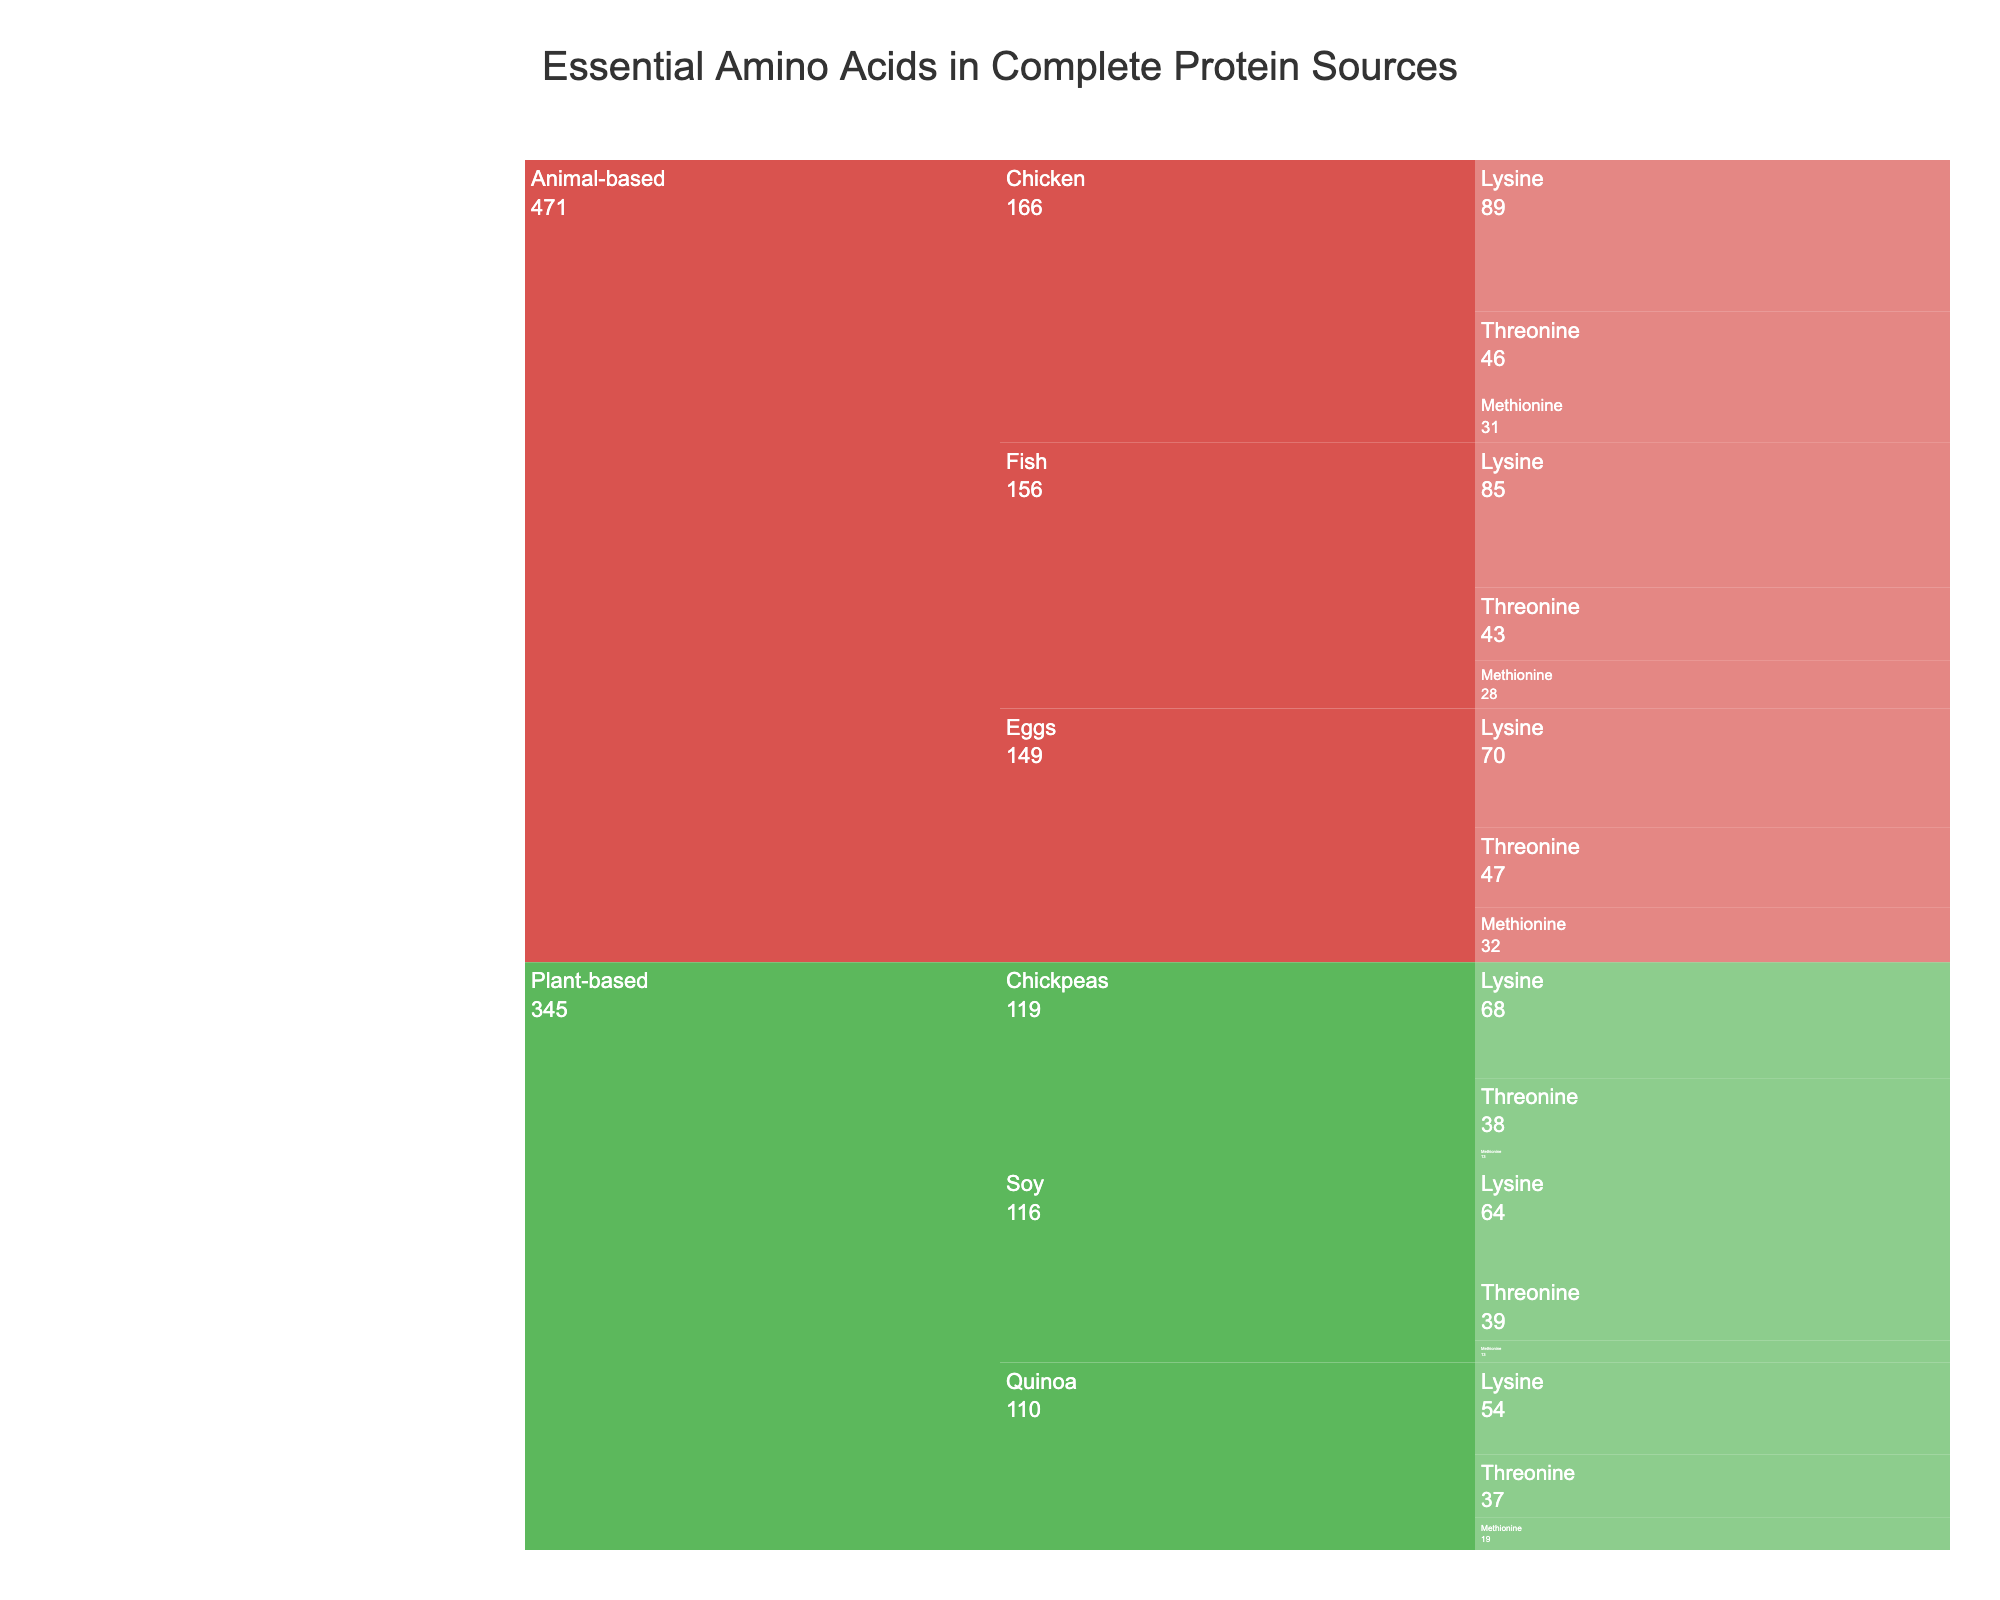What's the title of the figure? The title is located at the top of the chart and is used to describe the main topic or focus of the figure.
Answer: Essential Amino Acids in Complete Protein Sources Which category has the highest overall content of essential amino acids? To determine this, observe both 'Plant-based' and 'Animal-based' categories and compare their total values. 'Animal-based' has higher individual values across multiple protein sources.
Answer: Animal-based Which plant-based protein source has the highest lysine content? Find the lysine content values under the Plant-based category and compare them. The one with the highest value is the answer.
Answer: Chickpeas What are the essential amino acids found in chicken? Look at the breakdown under the 'Animal-based' category, then the 'Chicken' protein source to identify the essential amino acids listed.
Answer: Lysine, Methionine, Threonine How does the methionine content in quinoa compare to that in eggs? Locate and compare the methionine values for both quinoa and eggs under their respective categories in the chart.
Answer: Eggs have a higher methionine content What is the combined lysine content of the plant-based protein sources? Add the lysine values for Quinoa, Soy, and Chickpeas: 54 + 64 + 68.
Answer: 186 g per 100g protein Which protein source has the lowest threonine content? Compare the threonine values across all protein sources in both categories to find the smallest value.
Answer: Quinoa Are there more essential amino acid categories under 'Animal-based' or 'Plant-based' protein sources? Count the number of essential amino acid entries under both 'Animal-based' and 'Plant-based' categories. They should be equal as each source lists Lysine, Methionine, and Threonine.
Answer: Equal What is the difference in lysine content between fish and chicken? Subtract the lysine content of chicken from that of fish: 89 - 85.
Answer: 4 g per 100g protein 